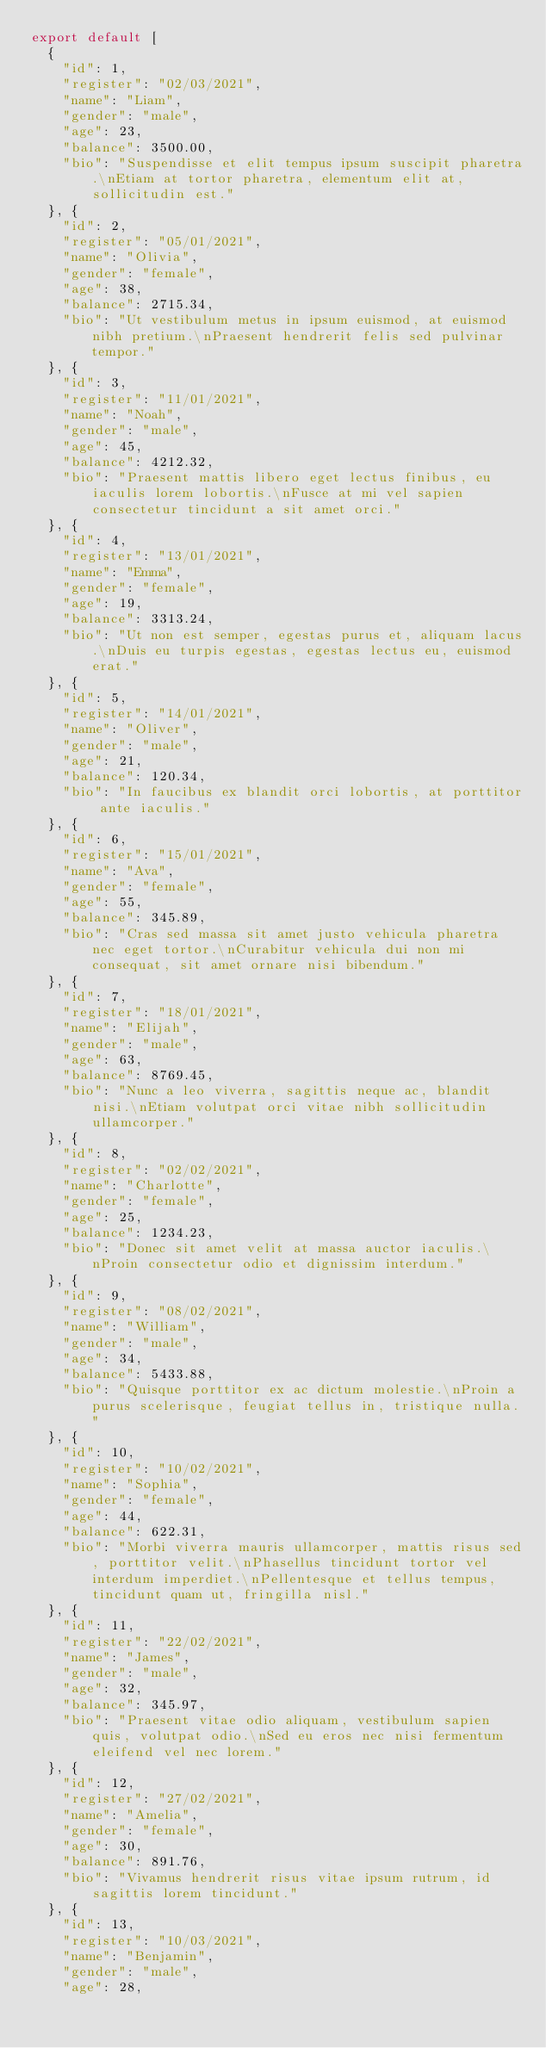<code> <loc_0><loc_0><loc_500><loc_500><_JavaScript_>export default [
  {
    "id": 1,
    "register": "02/03/2021",
    "name": "Liam",
    "gender": "male",
    "age": 23,
    "balance": 3500.00,
    "bio": "Suspendisse et elit tempus ipsum suscipit pharetra.\nEtiam at tortor pharetra, elementum elit at, sollicitudin est." 
  }, {
    "id": 2,
    "register": "05/01/2021",
    "name": "Olivia",
    "gender": "female",
    "age": 38,
    "balance": 2715.34,
    "bio": "Ut vestibulum metus in ipsum euismod, at euismod nibh pretium.\nPraesent hendrerit felis sed pulvinar tempor."
  }, {
    "id": 3,
    "register": "11/01/2021",
    "name": "Noah",
    "gender": "male",
    "age": 45,
    "balance": 4212.32,
    "bio": "Praesent mattis libero eget lectus finibus, eu iaculis lorem lobortis.\nFusce at mi vel sapien consectetur tincidunt a sit amet orci."
  }, {
    "id": 4,
    "register": "13/01/2021",
    "name": "Emma",
    "gender": "female",
    "age": 19,
    "balance": 3313.24,
    "bio": "Ut non est semper, egestas purus et, aliquam lacus.\nDuis eu turpis egestas, egestas lectus eu, euismod erat."
  }, {
    "id": 5,
    "register": "14/01/2021",
    "name": "Oliver",
    "gender": "male",
    "age": 21,
    "balance": 120.34,
    "bio": "In faucibus ex blandit orci lobortis, at porttitor ante iaculis."
  }, {
    "id": 6,
    "register": "15/01/2021",
    "name": "Ava",
    "gender": "female",
    "age": 55,
    "balance": 345.89,
    "bio": "Cras sed massa sit amet justo vehicula pharetra nec eget tortor.\nCurabitur vehicula dui non mi consequat, sit amet ornare nisi bibendum."
  }, {
    "id": 7,
    "register": "18/01/2021",
    "name": "Elijah",
    "gender": "male",
    "age": 63,
    "balance": 8769.45,
    "bio": "Nunc a leo viverra, sagittis neque ac, blandit nisi.\nEtiam volutpat orci vitae nibh sollicitudin ullamcorper."
  }, {
    "id": 8,
    "register": "02/02/2021",
    "name": "Charlotte",
    "gender": "female",
    "age": 25,
    "balance": 1234.23,
    "bio": "Donec sit amet velit at massa auctor iaculis.\nProin consectetur odio et dignissim interdum."
  }, {
    "id": 9,
    "register": "08/02/2021",
    "name": "William",
    "gender": "male",
    "age": 34,
    "balance": 5433.88,
    "bio": "Quisque porttitor ex ac dictum molestie.\nProin a purus scelerisque, feugiat tellus in, tristique nulla."
  }, {
    "id": 10,
    "register": "10/02/2021",
    "name": "Sophia",
    "gender": "female",
    "age": 44,
    "balance": 622.31,
    "bio": "Morbi viverra mauris ullamcorper, mattis risus sed, porttitor velit.\nPhasellus tincidunt tortor vel interdum imperdiet.\nPellentesque et tellus tempus, tincidunt quam ut, fringilla nisl."
  }, {
    "id": 11,
    "register": "22/02/2021",
    "name": "James",
    "gender": "male",
    "age": 32,
    "balance": 345.97,
    "bio": "Praesent vitae odio aliquam, vestibulum sapien quis, volutpat odio.\nSed eu eros nec nisi fermentum eleifend vel nec lorem."
  }, {
    "id": 12,
    "register": "27/02/2021",
    "name": "Amelia",
    "gender": "female",
    "age": 30,
    "balance": 891.76,
    "bio": "Vivamus hendrerit risus vitae ipsum rutrum, id sagittis lorem tincidunt."
  }, {
    "id": 13,
    "register": "10/03/2021",
    "name": "Benjamin",
    "gender": "male",
    "age": 28,</code> 